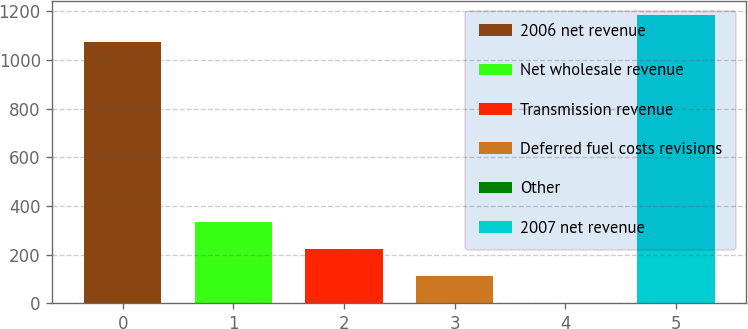<chart> <loc_0><loc_0><loc_500><loc_500><bar_chart><fcel>2006 net revenue<fcel>Net wholesale revenue<fcel>Transmission revenue<fcel>Deferred fuel costs revisions<fcel>Other<fcel>2007 net revenue<nl><fcel>1074.5<fcel>334.93<fcel>224.12<fcel>113.31<fcel>2.5<fcel>1185.31<nl></chart> 